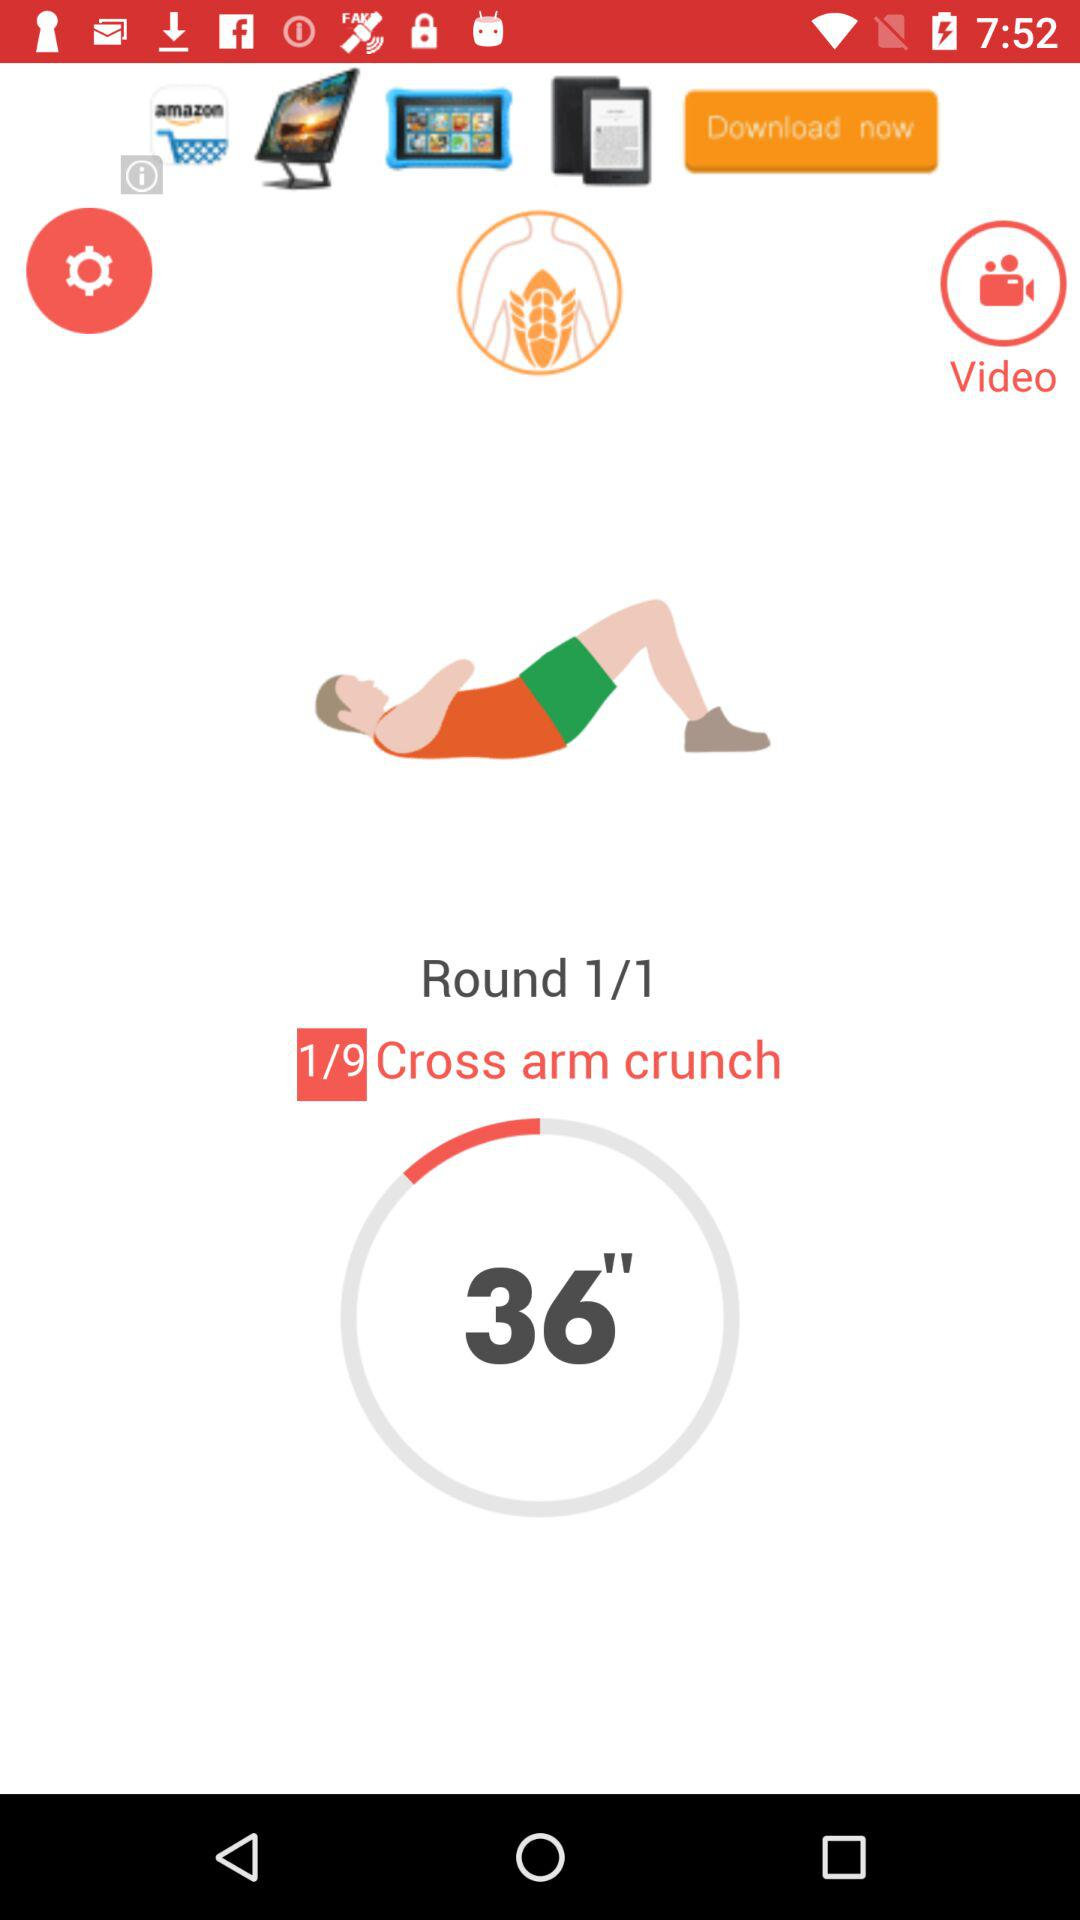Which exercise videos are available?
When the provided information is insufficient, respond with <no answer>. <no answer> 